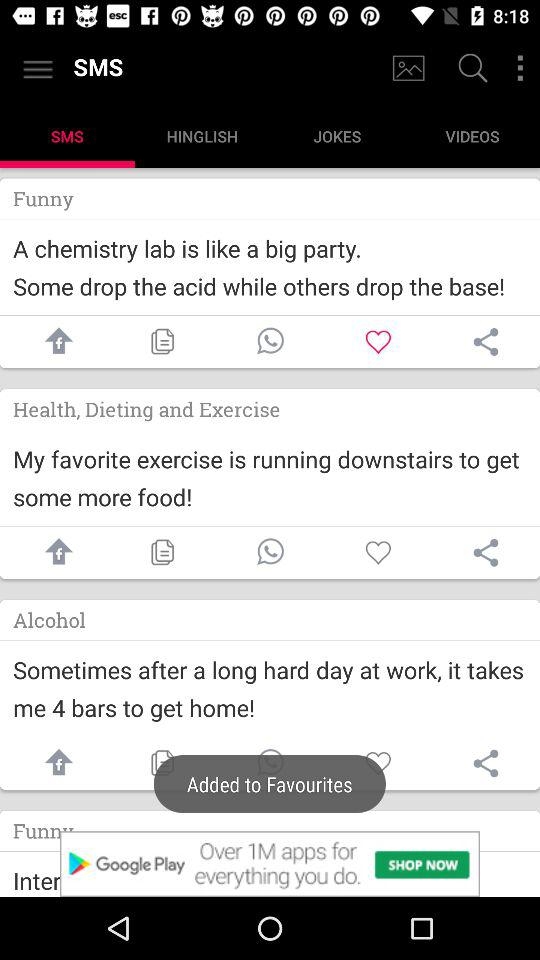What tab is selected currently? The tab is "SMS". 